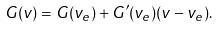Convert formula to latex. <formula><loc_0><loc_0><loc_500><loc_500>G ( v ) = G ( v _ { e } ) + G ^ { \prime } ( v _ { e } ) ( v - v _ { e } ) .</formula> 